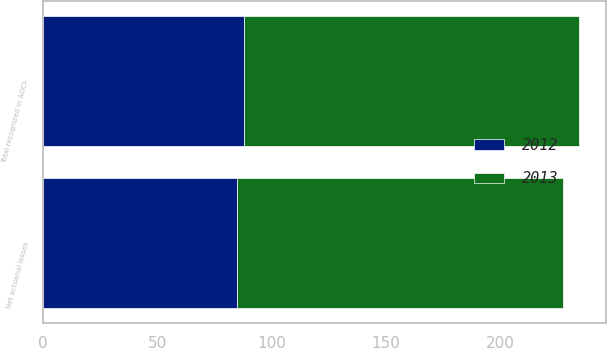Convert chart to OTSL. <chart><loc_0><loc_0><loc_500><loc_500><stacked_bar_chart><ecel><fcel>Net actuarial losses<fcel>Total recognized in AOCI-<nl><fcel>2012<fcel>84.6<fcel>87.9<nl><fcel>2013<fcel>142.7<fcel>146.7<nl></chart> 